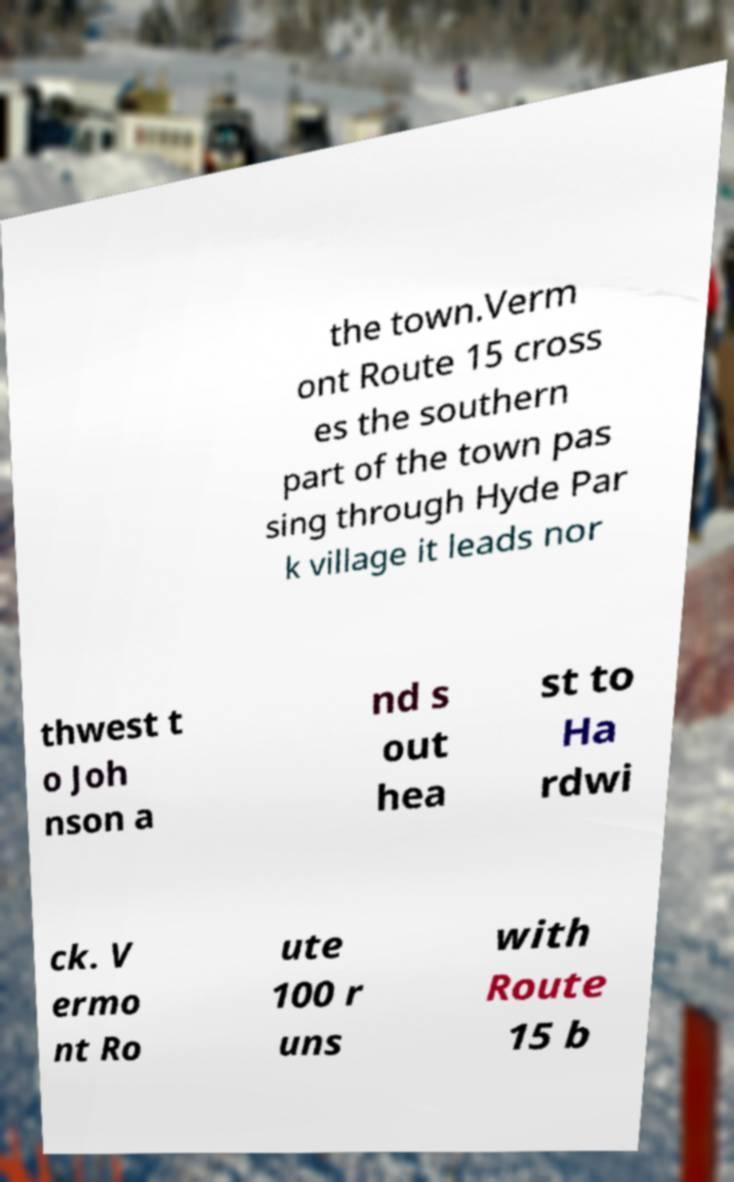Could you extract and type out the text from this image? the town.Verm ont Route 15 cross es the southern part of the town pas sing through Hyde Par k village it leads nor thwest t o Joh nson a nd s out hea st to Ha rdwi ck. V ermo nt Ro ute 100 r uns with Route 15 b 